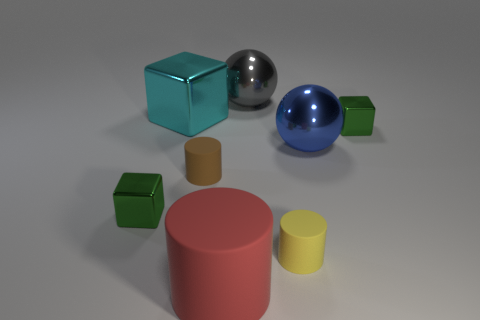Add 1 tiny shiny spheres. How many objects exist? 9 Subtract all balls. How many objects are left? 6 Add 2 small matte things. How many small matte things exist? 4 Subtract 1 brown cylinders. How many objects are left? 7 Subtract all large cylinders. Subtract all blue objects. How many objects are left? 6 Add 5 small cylinders. How many small cylinders are left? 7 